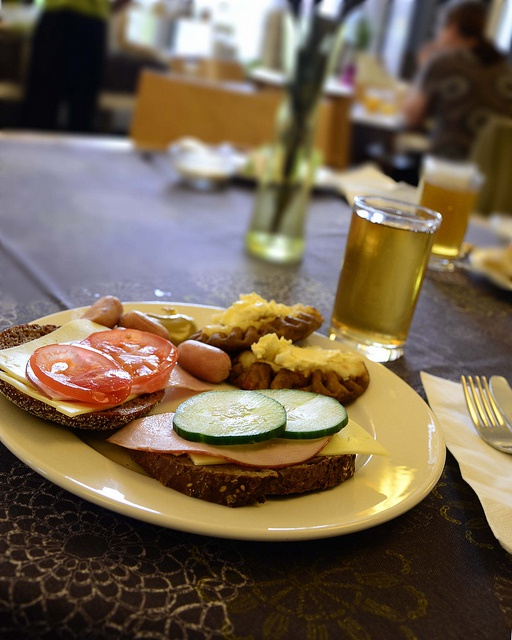Describe the objects in this image and their specific colors. I can see dining table in darkgray, black, and gray tones, sandwich in darkgray, black, lightgray, maroon, and brown tones, cup in darkgray, olive, and maroon tones, people in darkgray, black, gray, and maroon tones, and people in darkgray, black, darkgreen, and gray tones in this image. 